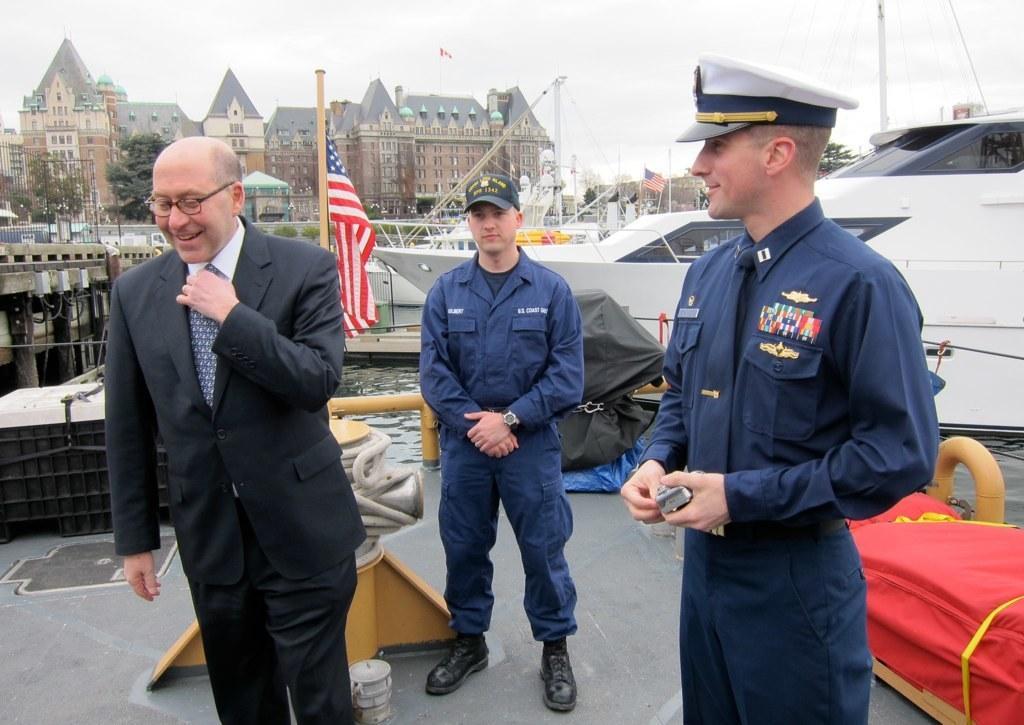In one or two sentences, can you explain what this image depicts? In this image we can see three men are standing, in the background there are some buildings, trees and a flag. 